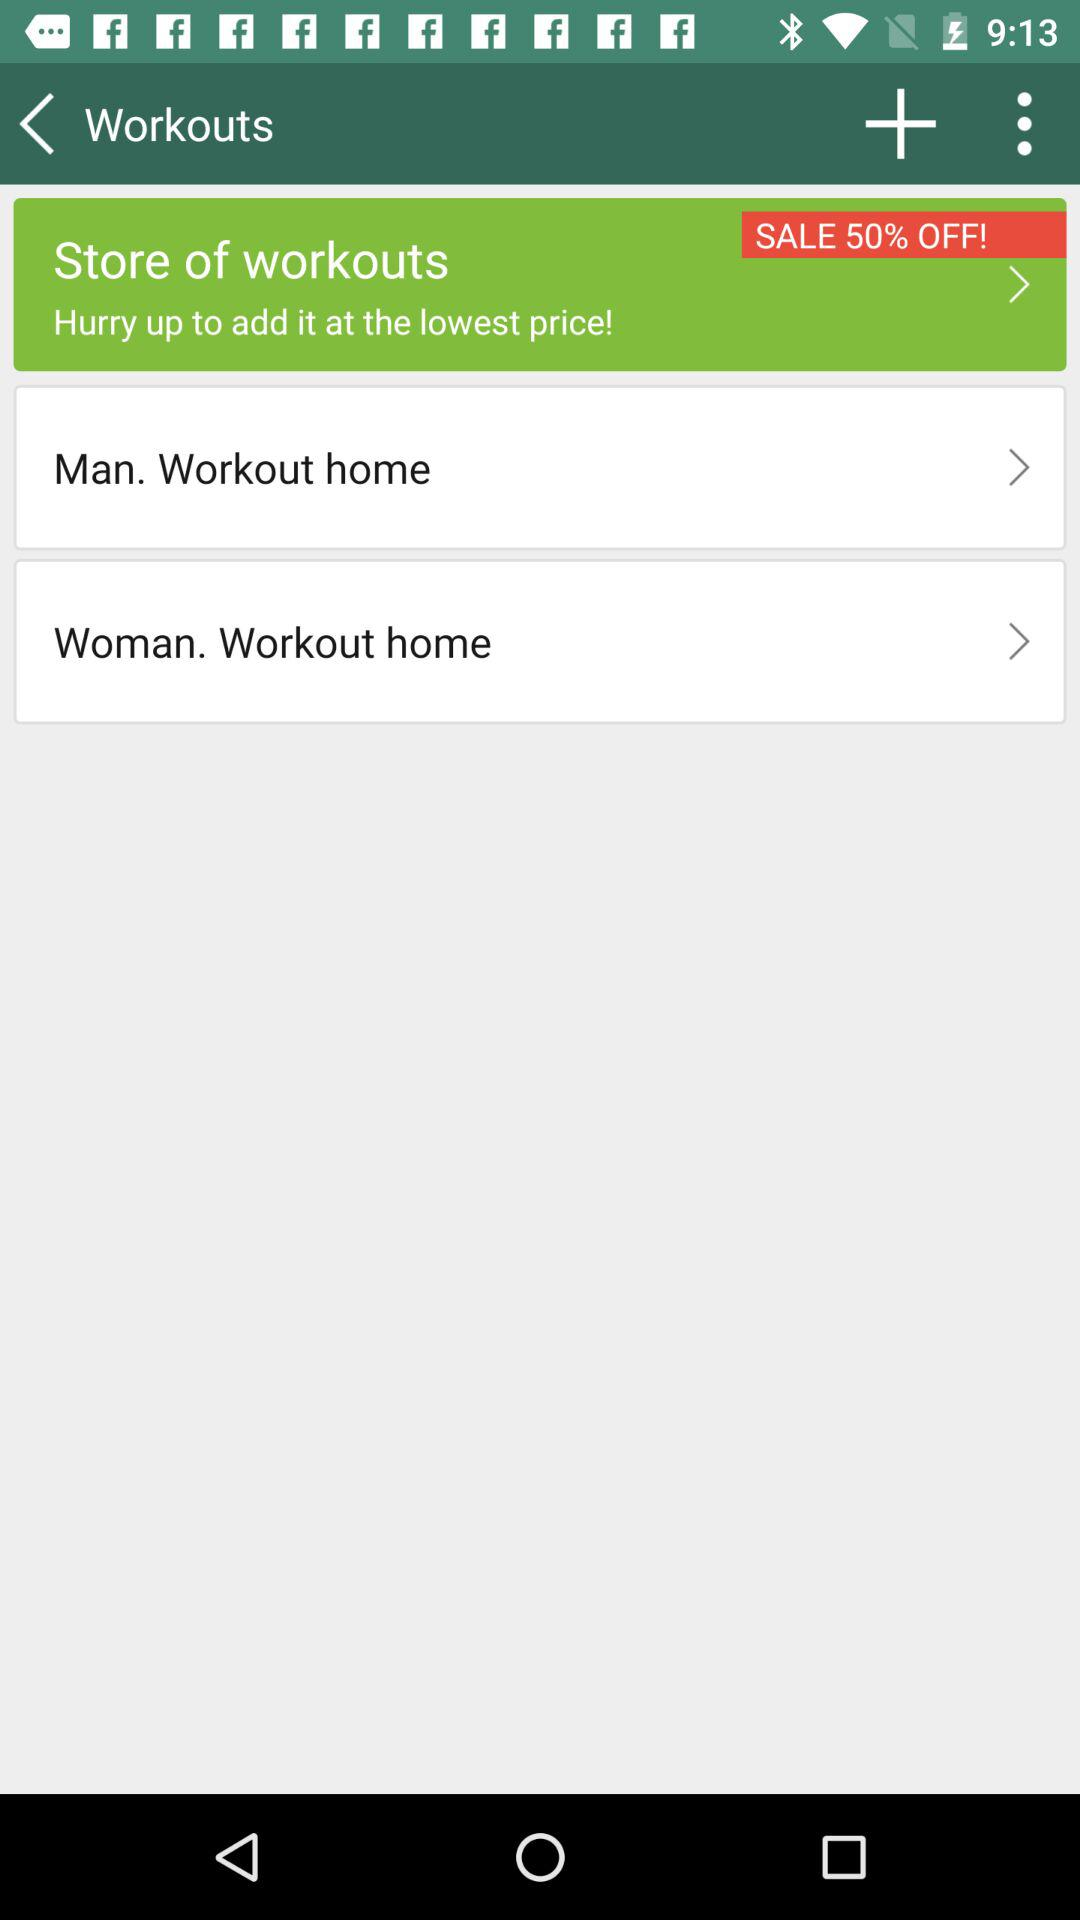What is the discount on the store? The discount is 50%. 